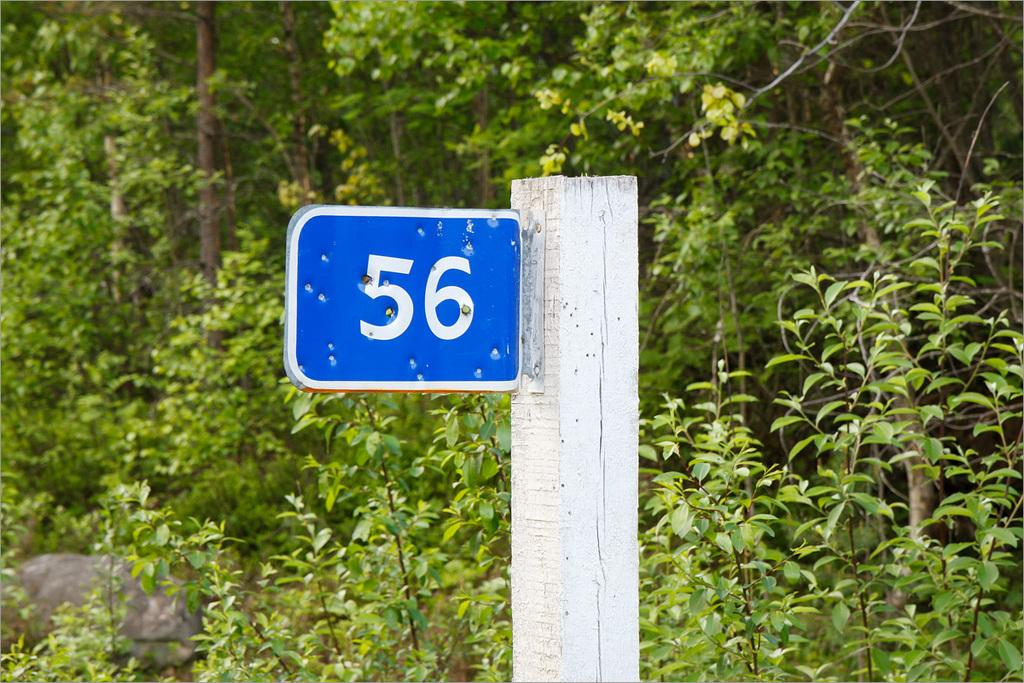What is the primary color of the board in the image? The primary color of the board in the image is blue. What number is written on the board? The number "56" is written on the board. How is the board supported or held up in the image? The board is attached to a wooden pole. What can be seen in the background of the image? There are trees in the background of the image. What type of celery is being used to hold up the board in the image? There is no celery present in the image; the board is attached to a wooden pole. Can you tell me how many people are in the group shown in the image? There is no group of people present in the image; it only features the blue color board and the wooden pole. 